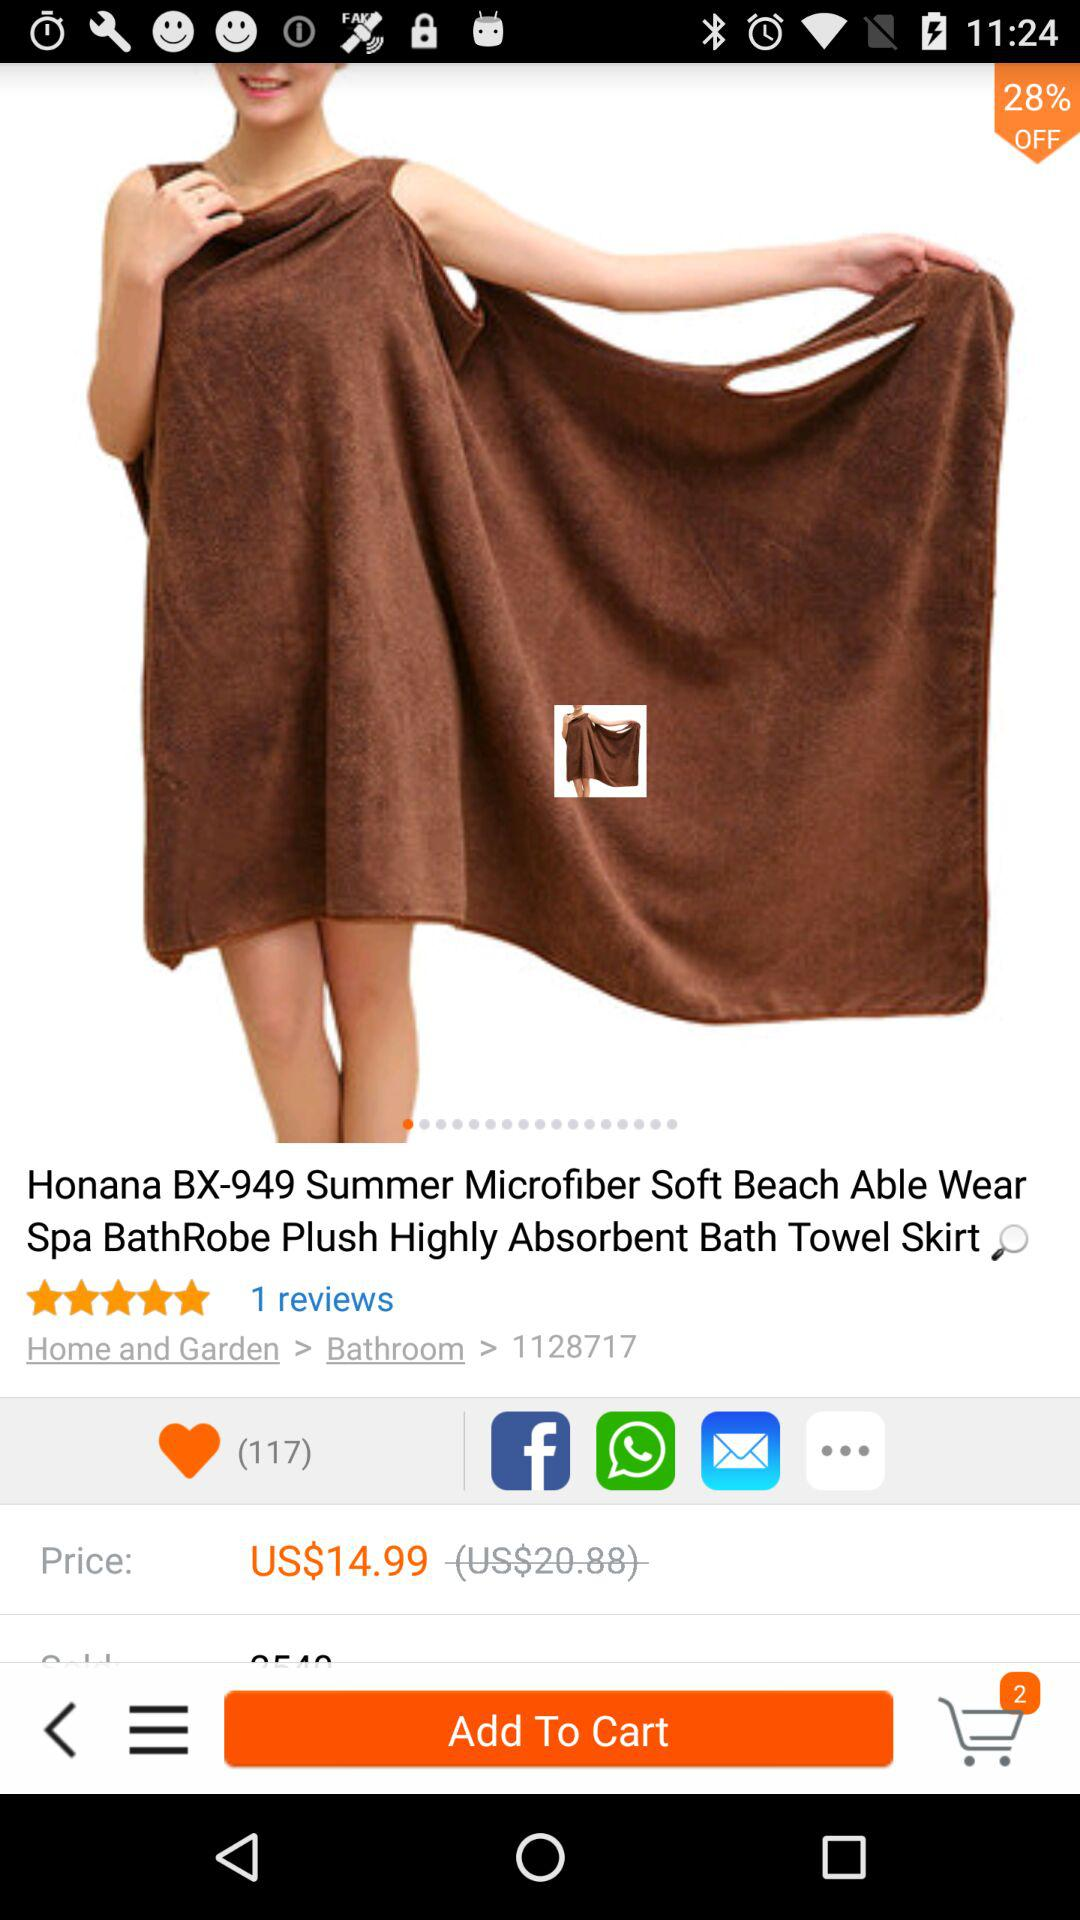What is the price of "Honana BX-949 Summer Microfiber Soft Beach Able Wear Spa BathRobe Plush Highly Absorbent Bath Towel Skirt"? The price is US$14.99. 